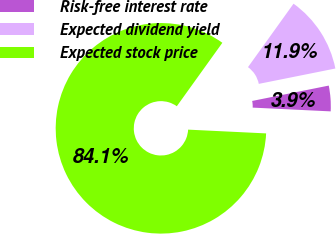Convert chart to OTSL. <chart><loc_0><loc_0><loc_500><loc_500><pie_chart><fcel>Risk-free interest rate<fcel>Expected dividend yield<fcel>Expected stock price<nl><fcel>3.92%<fcel>11.94%<fcel>84.14%<nl></chart> 